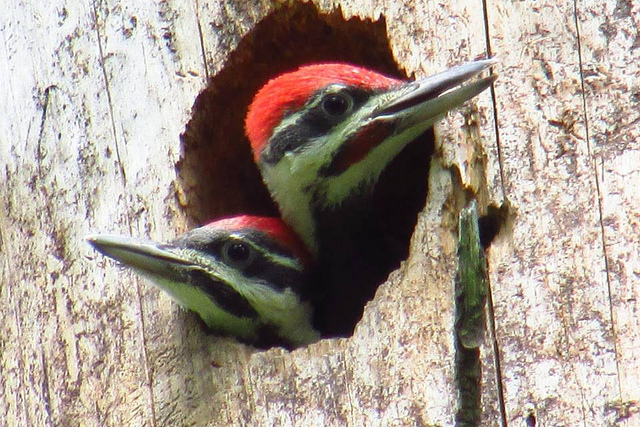How many vases are empty? The question seems to be a mismatch as the image features two woodpeckers in a tree hole and not vases. To correct, a more relevant question would be: 'How many woodpeckers are visible in the tree hole?', and the answer to that would be two. 